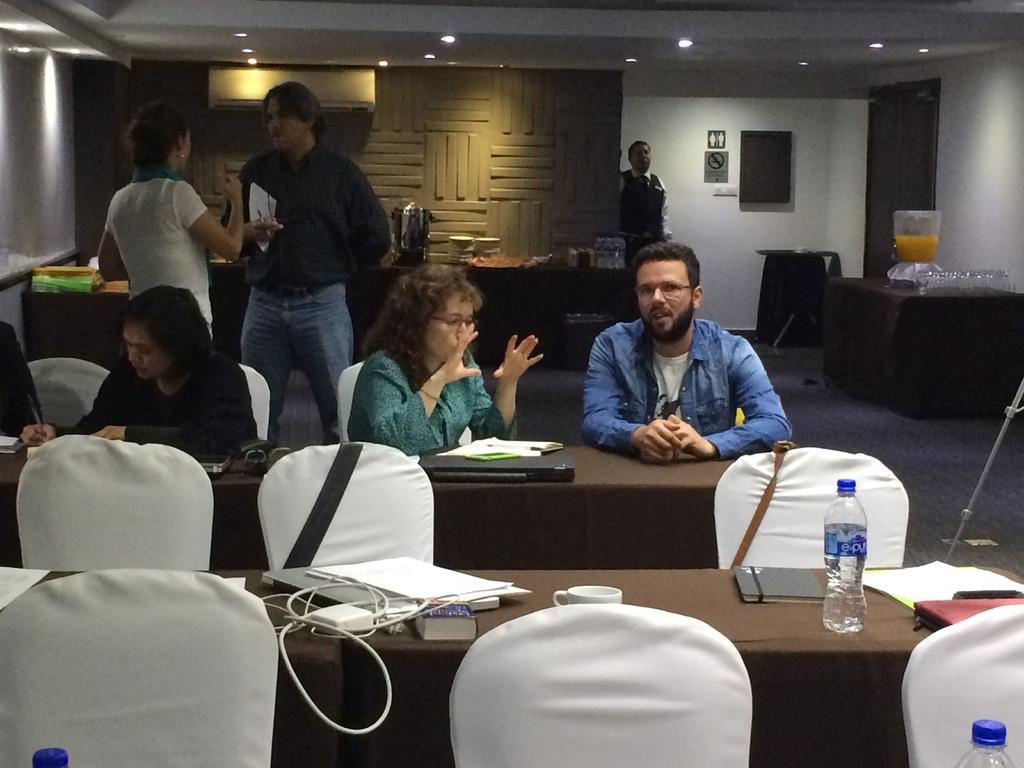What are the people in the image doing? There is a couple standing and talking, and two other couples are sitting at a table and talking. Can you describe the setting of the image? A man is waiting at the door, and food items are arranged in a buffet. What type of ocean can be seen in the background of the image? There is no ocean visible in the image; it is focused on the people and the setting indoors. Are there any bears present in the image? No, there are no bears present in the image. 